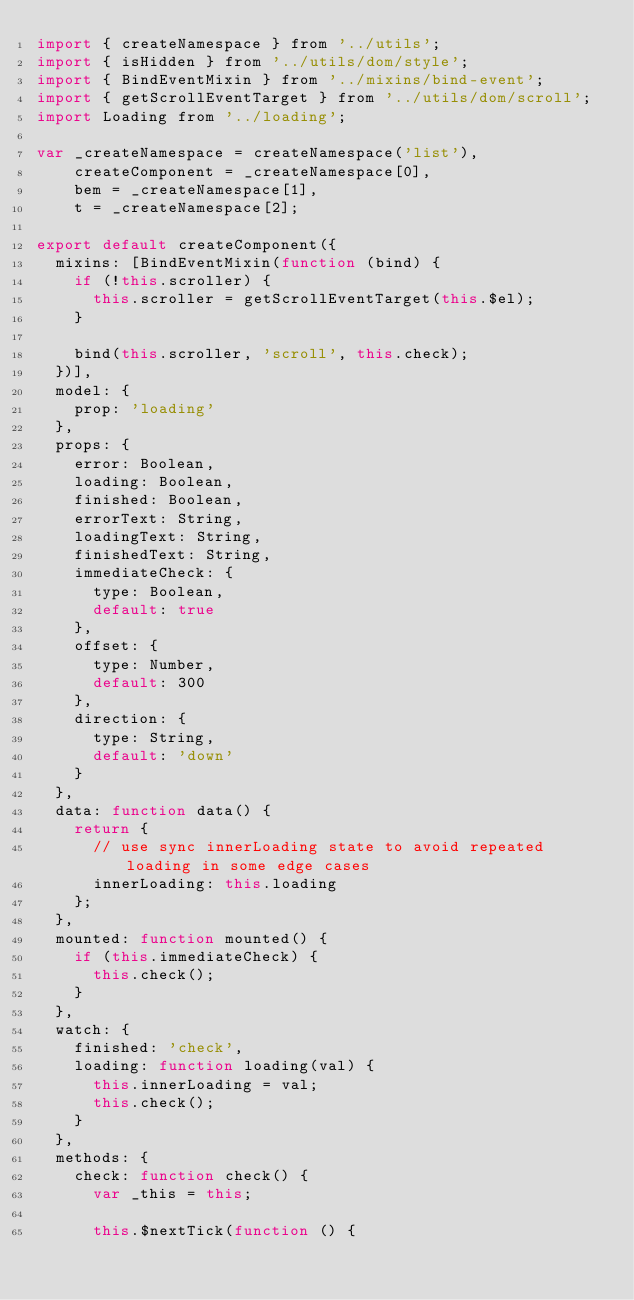<code> <loc_0><loc_0><loc_500><loc_500><_JavaScript_>import { createNamespace } from '../utils';
import { isHidden } from '../utils/dom/style';
import { BindEventMixin } from '../mixins/bind-event';
import { getScrollEventTarget } from '../utils/dom/scroll';
import Loading from '../loading';

var _createNamespace = createNamespace('list'),
    createComponent = _createNamespace[0],
    bem = _createNamespace[1],
    t = _createNamespace[2];

export default createComponent({
  mixins: [BindEventMixin(function (bind) {
    if (!this.scroller) {
      this.scroller = getScrollEventTarget(this.$el);
    }

    bind(this.scroller, 'scroll', this.check);
  })],
  model: {
    prop: 'loading'
  },
  props: {
    error: Boolean,
    loading: Boolean,
    finished: Boolean,
    errorText: String,
    loadingText: String,
    finishedText: String,
    immediateCheck: {
      type: Boolean,
      default: true
    },
    offset: {
      type: Number,
      default: 300
    },
    direction: {
      type: String,
      default: 'down'
    }
  },
  data: function data() {
    return {
      // use sync innerLoading state to avoid repeated loading in some edge cases
      innerLoading: this.loading
    };
  },
  mounted: function mounted() {
    if (this.immediateCheck) {
      this.check();
    }
  },
  watch: {
    finished: 'check',
    loading: function loading(val) {
      this.innerLoading = val;
      this.check();
    }
  },
  methods: {
    check: function check() {
      var _this = this;

      this.$nextTick(function () {</code> 